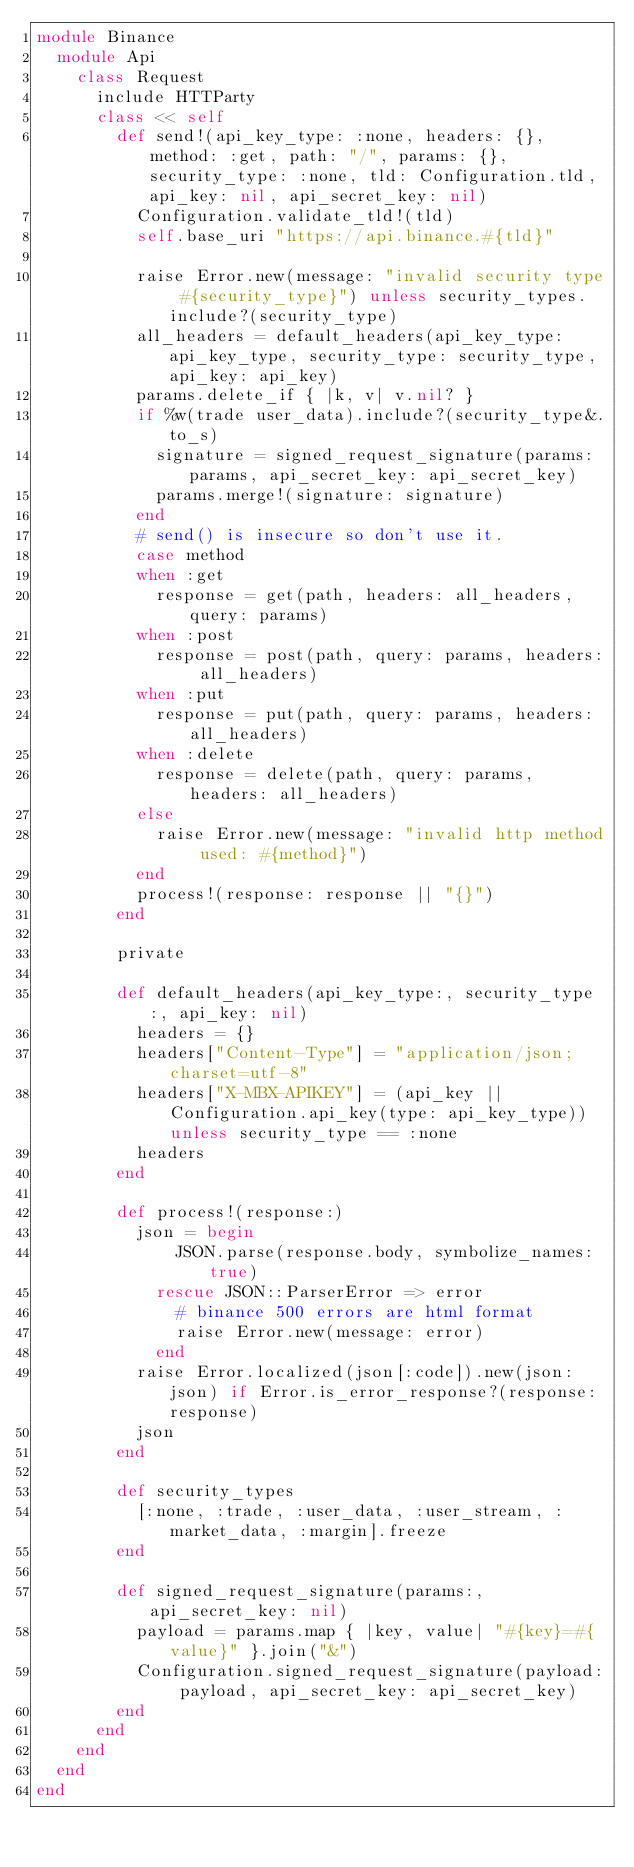Convert code to text. <code><loc_0><loc_0><loc_500><loc_500><_Ruby_>module Binance
  module Api
    class Request
      include HTTParty
      class << self
        def send!(api_key_type: :none, headers: {}, method: :get, path: "/", params: {}, security_type: :none, tld: Configuration.tld, api_key: nil, api_secret_key: nil)
          Configuration.validate_tld!(tld)
          self.base_uri "https://api.binance.#{tld}"

          raise Error.new(message: "invalid security type #{security_type}") unless security_types.include?(security_type)
          all_headers = default_headers(api_key_type: api_key_type, security_type: security_type, api_key: api_key)
          params.delete_if { |k, v| v.nil? }
          if %w(trade user_data).include?(security_type&.to_s)
            signature = signed_request_signature(params: params, api_secret_key: api_secret_key)
            params.merge!(signature: signature)
          end
          # send() is insecure so don't use it.
          case method
          when :get
            response = get(path, headers: all_headers, query: params)
          when :post
            response = post(path, query: params, headers: all_headers)
          when :put
            response = put(path, query: params, headers: all_headers)
          when :delete
            response = delete(path, query: params, headers: all_headers)
          else
            raise Error.new(message: "invalid http method used: #{method}")
          end
          process!(response: response || "{}")
        end

        private

        def default_headers(api_key_type:, security_type:, api_key: nil)
          headers = {}
          headers["Content-Type"] = "application/json; charset=utf-8"
          headers["X-MBX-APIKEY"] = (api_key || Configuration.api_key(type: api_key_type)) unless security_type == :none
          headers
        end

        def process!(response:)
          json = begin
              JSON.parse(response.body, symbolize_names: true)
            rescue JSON::ParserError => error
              # binance 500 errors are html format
              raise Error.new(message: error)
            end
          raise Error.localized(json[:code]).new(json: json) if Error.is_error_response?(response: response)
          json
        end

        def security_types
          [:none, :trade, :user_data, :user_stream, :market_data, :margin].freeze
        end

        def signed_request_signature(params:, api_secret_key: nil)
          payload = params.map { |key, value| "#{key}=#{value}" }.join("&")
          Configuration.signed_request_signature(payload: payload, api_secret_key: api_secret_key)
        end
      end
    end
  end
end
</code> 